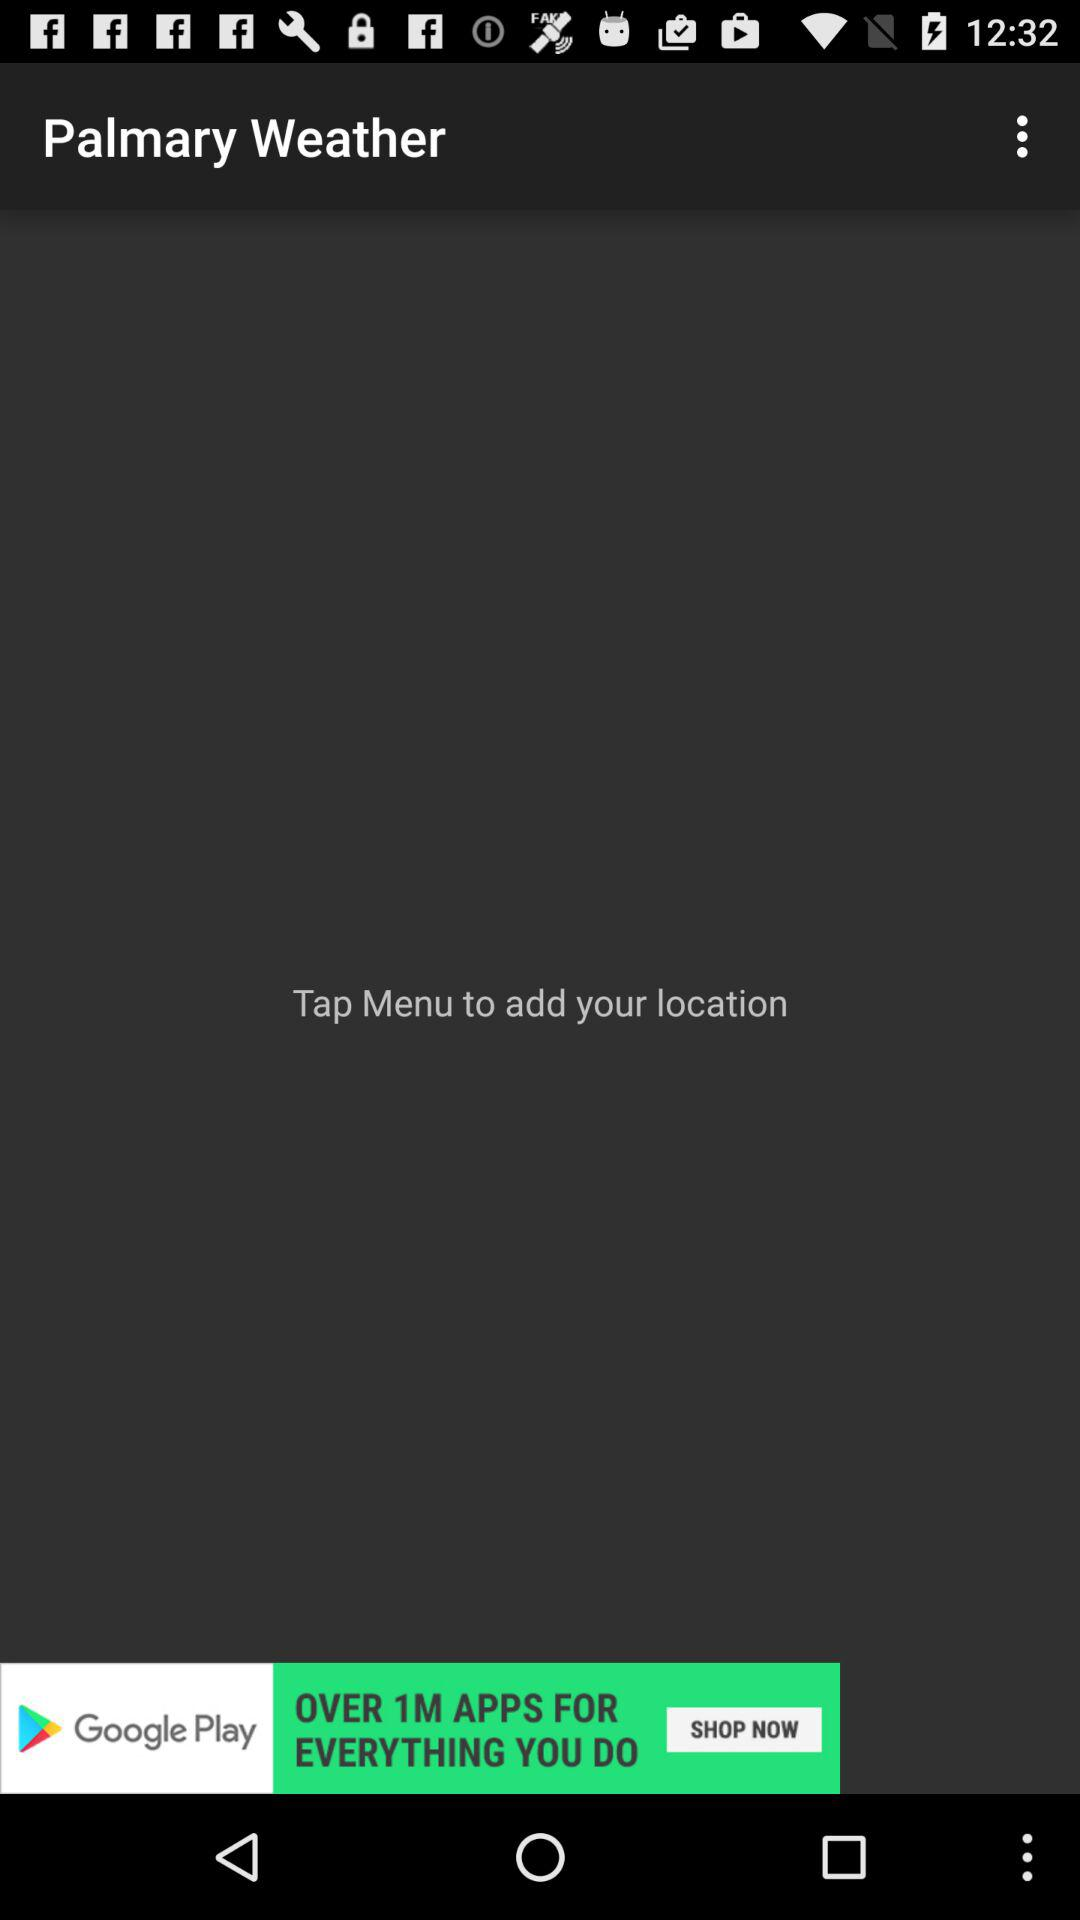What is the name of the application? The application name is "Palmary Weather". 